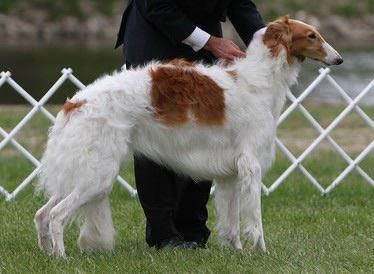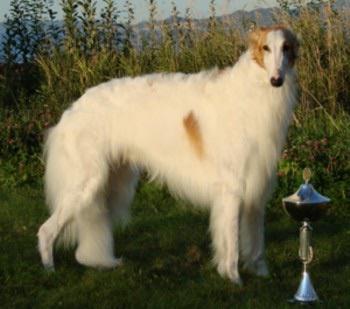The first image is the image on the left, the second image is the image on the right. Evaluate the accuracy of this statement regarding the images: "At least three white dogs are shown.". Is it true? Answer yes or no. No. The first image is the image on the left, the second image is the image on the right. Given the left and right images, does the statement "There are more than two dogs." hold true? Answer yes or no. No. 